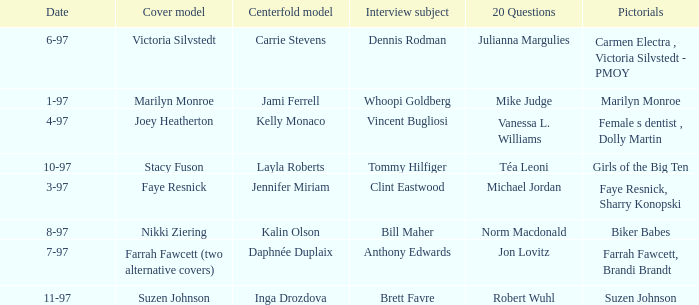What is the name of the cover model on 3-97? Faye Resnick. 